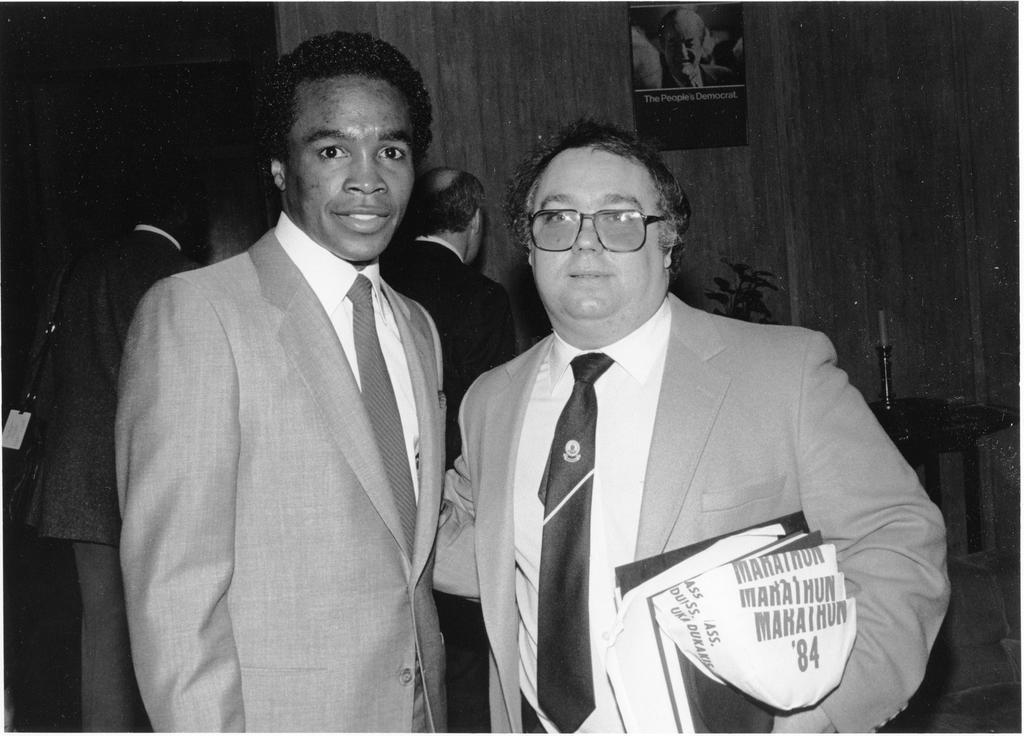What is the color scheme of the image? The image is black and white. How many people are visible in the image? There are a few people in the image. What is on the table in the image? There is an object on the table in the image. What type of vegetation is present in the image? There is a plant in the image. What is the background of the image? There is a wall in the image. What is hanging on the wall in the image? There is a poster on the wall in the image. What type of farm animals can be seen in the image? There are no farm animals present in the image; it is a black and white image with a few people, a table, a plant, a wall, and a poster, but no farm animals are visible. 